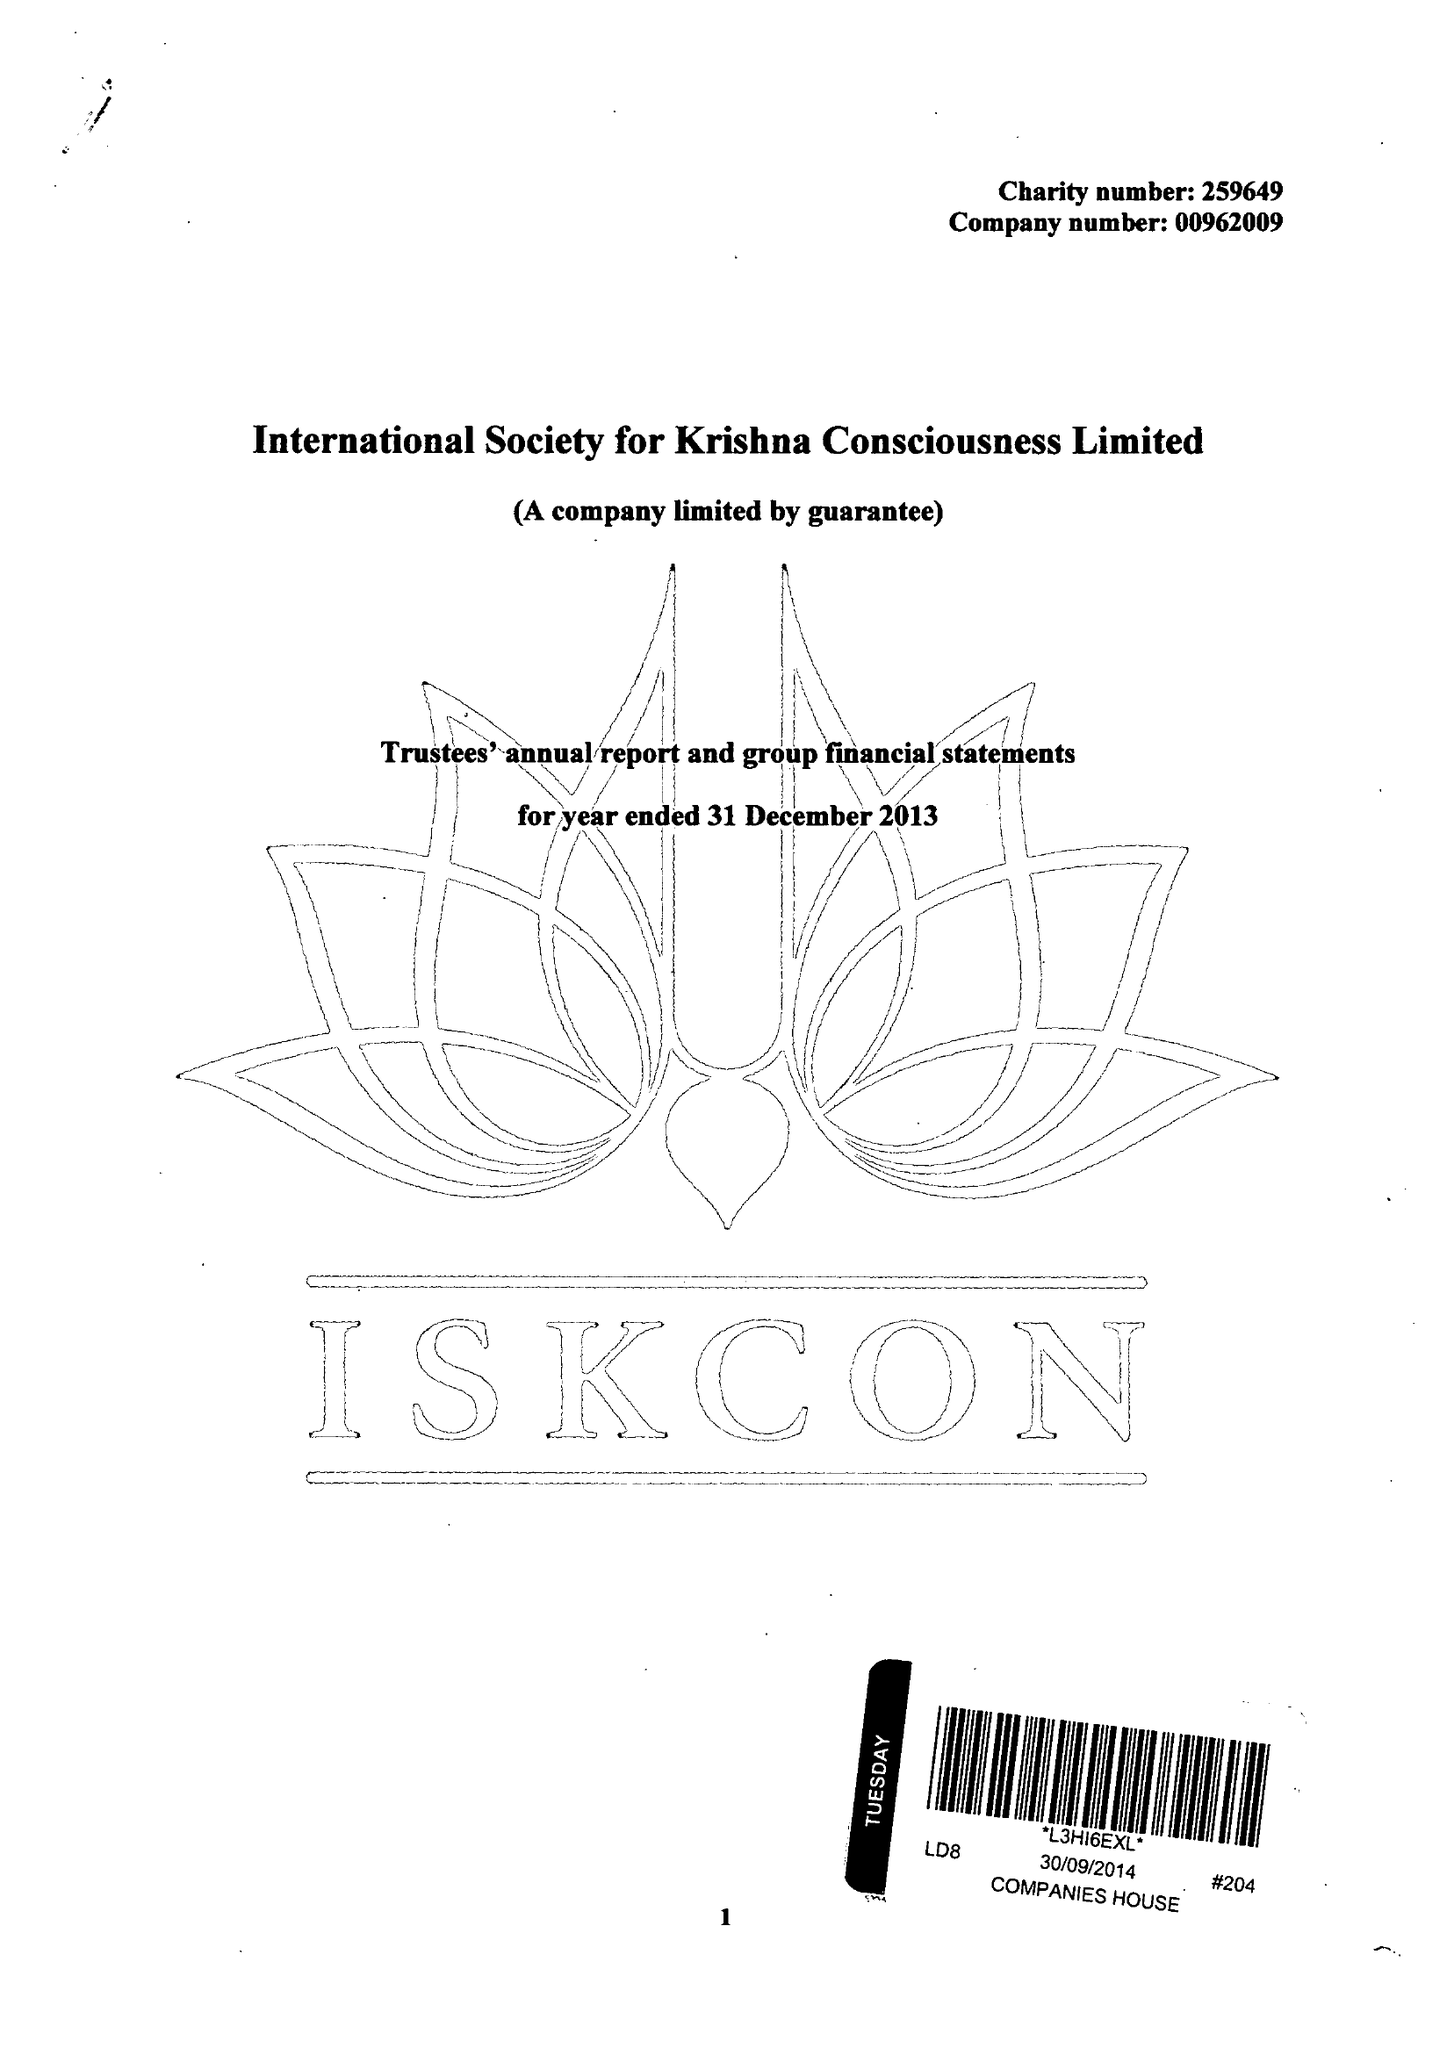What is the value for the charity_name?
Answer the question using a single word or phrase. International Society For Krishna Consciousness Ltd. 